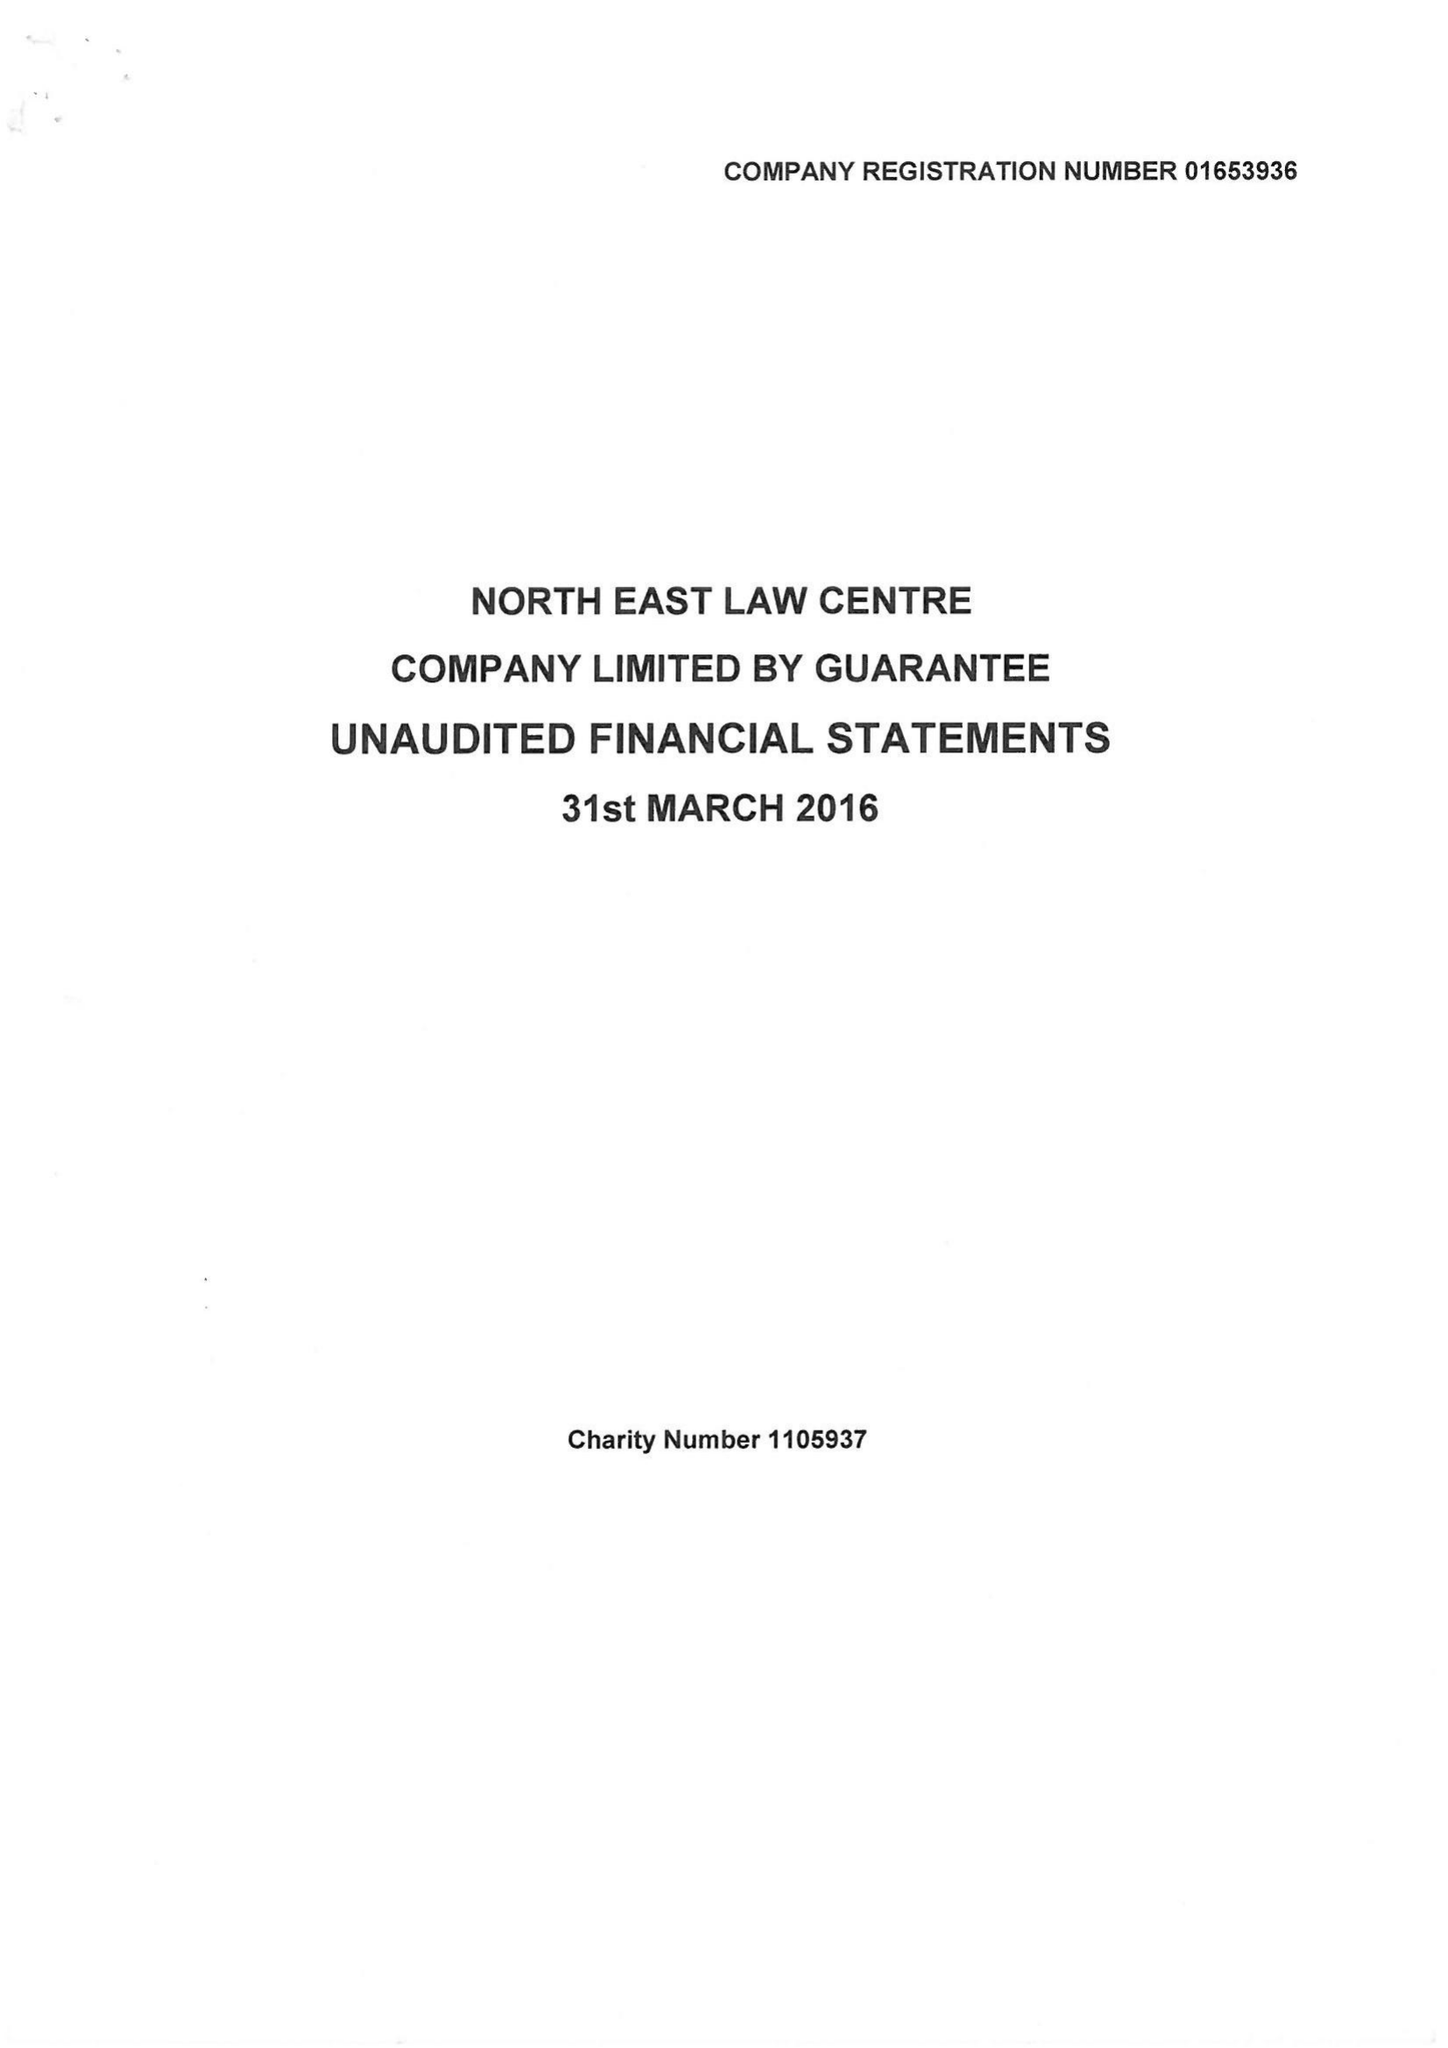What is the value for the report_date?
Answer the question using a single word or phrase. 2016-03-31 